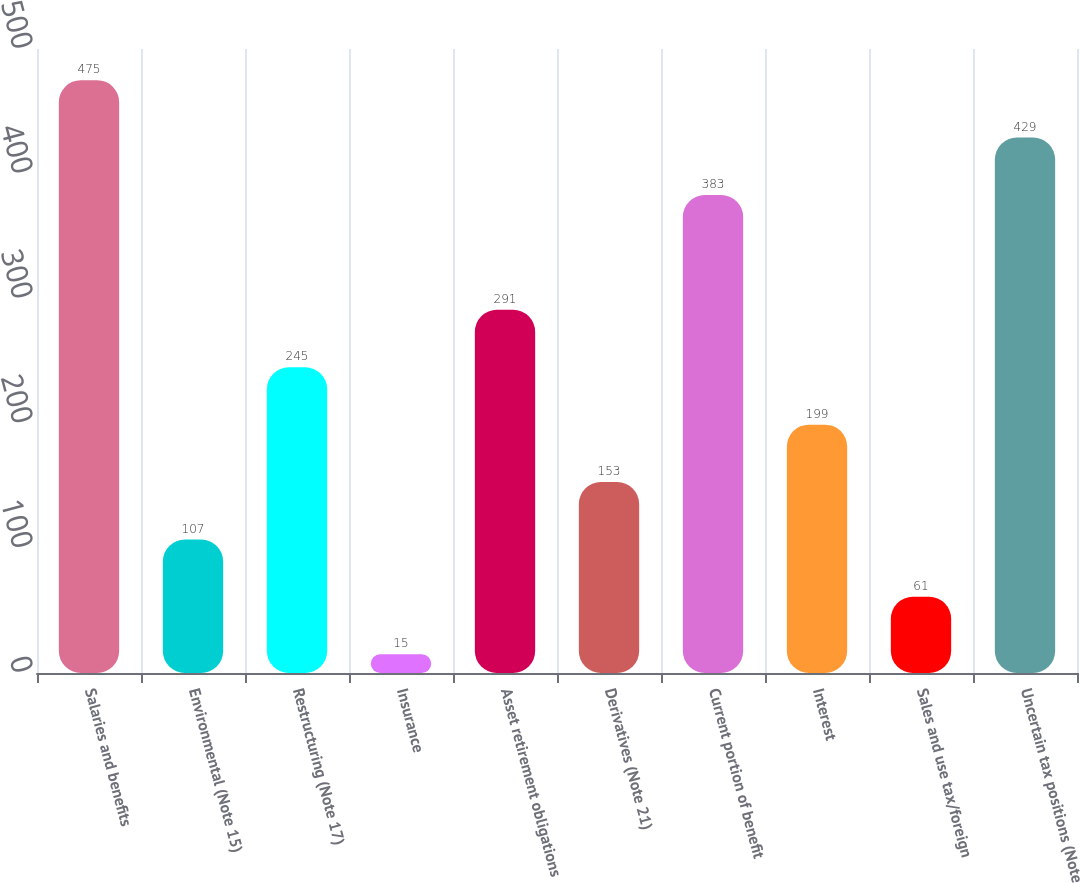Convert chart to OTSL. <chart><loc_0><loc_0><loc_500><loc_500><bar_chart><fcel>Salaries and benefits<fcel>Environmental (Note 15)<fcel>Restructuring (Note 17)<fcel>Insurance<fcel>Asset retirement obligations<fcel>Derivatives (Note 21)<fcel>Current portion of benefit<fcel>Interest<fcel>Sales and use tax/foreign<fcel>Uncertain tax positions (Note<nl><fcel>475<fcel>107<fcel>245<fcel>15<fcel>291<fcel>153<fcel>383<fcel>199<fcel>61<fcel>429<nl></chart> 